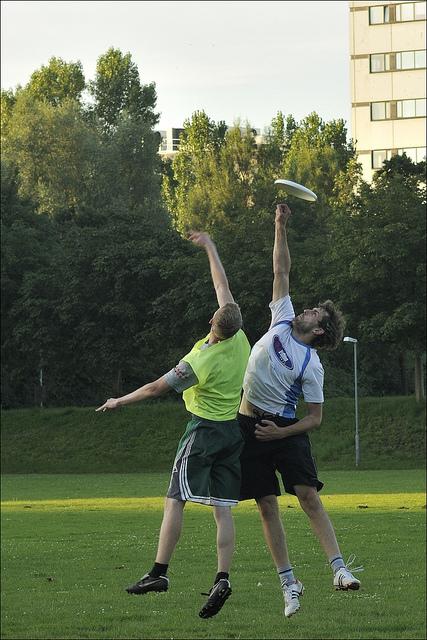How many men can you see?
Concise answer only. 2. Which male is ready to hit a tennis ball with a racket?
Be succinct. None. Are they in a park?
Give a very brief answer. Yes. Did either of the men catch the frisbee?
Write a very short answer. No. 